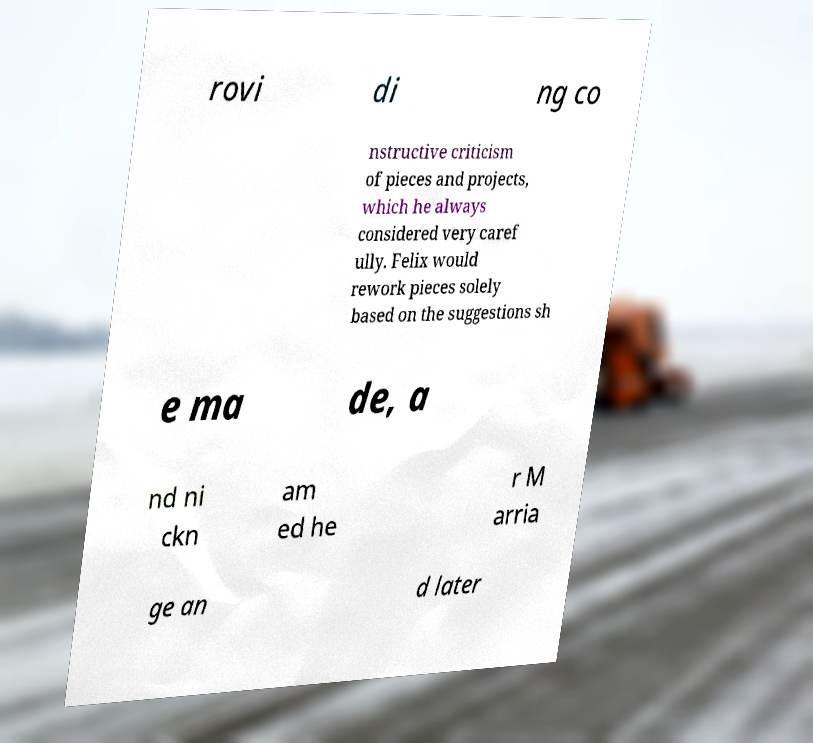For documentation purposes, I need the text within this image transcribed. Could you provide that? rovi di ng co nstructive criticism of pieces and projects, which he always considered very caref ully. Felix would rework pieces solely based on the suggestions sh e ma de, a nd ni ckn am ed he r M arria ge an d later 